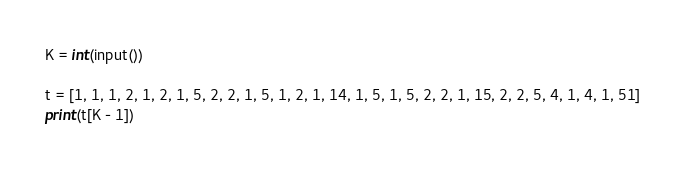Convert code to text. <code><loc_0><loc_0><loc_500><loc_500><_Go_>K = int(input())

t = [1, 1, 1, 2, 1, 2, 1, 5, 2, 2, 1, 5, 1, 2, 1, 14, 1, 5, 1, 5, 2, 2, 1, 15, 2, 2, 5, 4, 1, 4, 1, 51]
print(t[K - 1])
</code> 